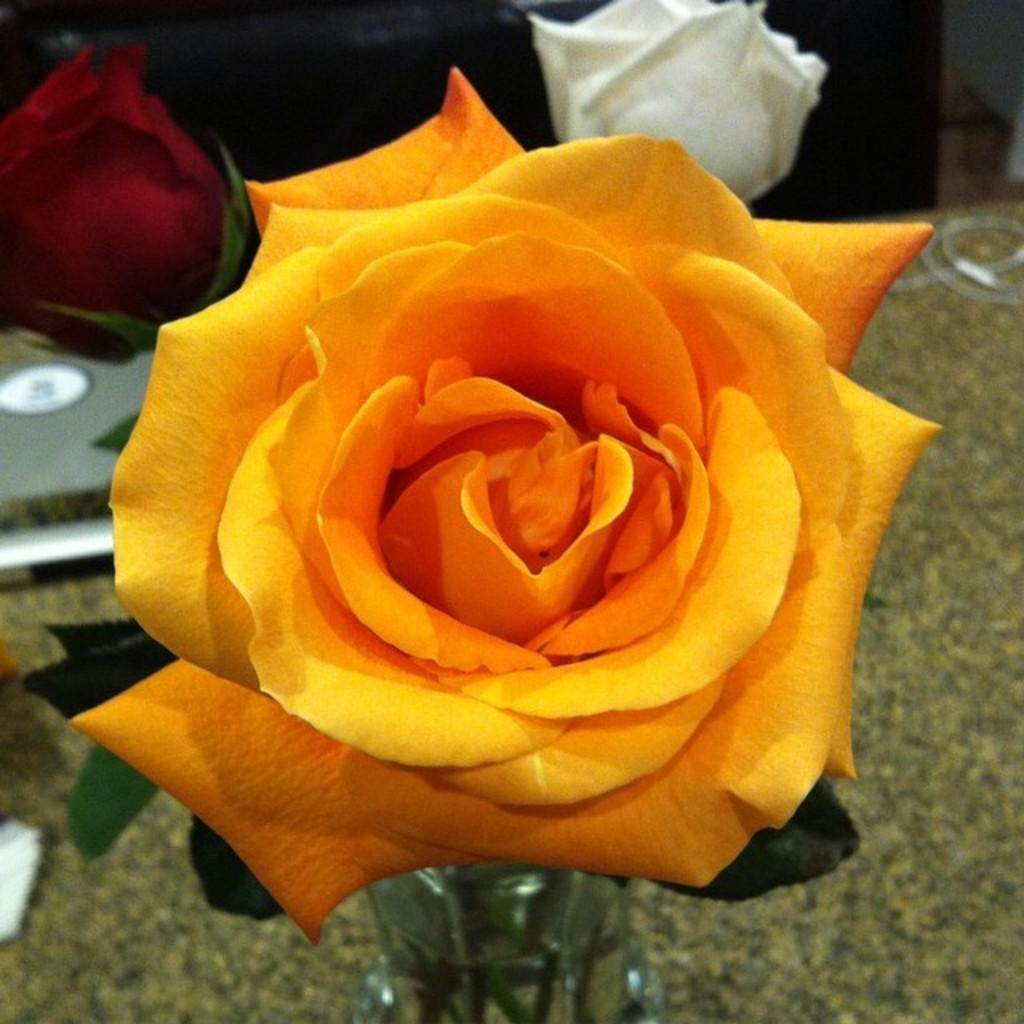What type of flowers are in the image? There are roses in the image. How are the roses arranged in the image? The roses are placed in a flower vase. What piece of furniture is visible in the image? There is a table in the image. What is placed on the table in the image? There is an object placed on the table. Can you tell me how many times the roses have experienced regret in the image? There is no indication of emotions or experiences in the image, so it is not possible to determine if the roses have experienced regret. 